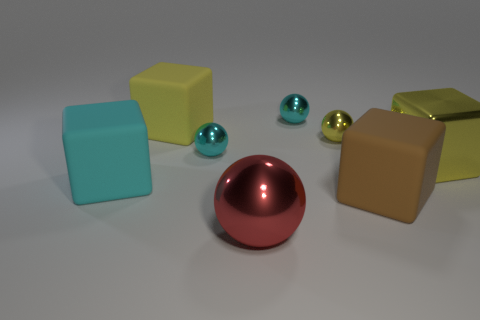What color is the large rubber thing left of the cube that is behind the yellow metal ball? cyan 